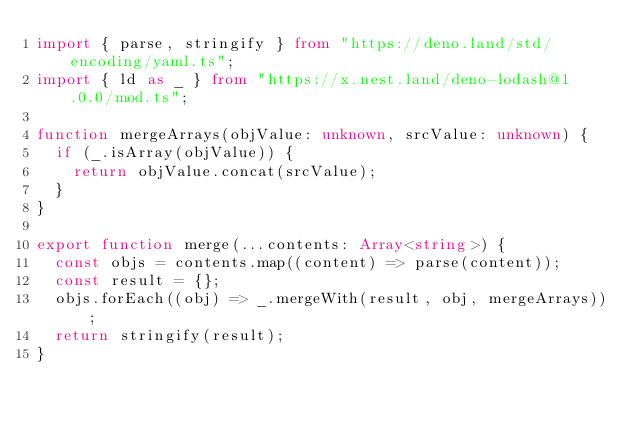<code> <loc_0><loc_0><loc_500><loc_500><_TypeScript_>import { parse, stringify } from "https://deno.land/std/encoding/yaml.ts";
import { ld as _ } from "https://x.nest.land/deno-lodash@1.0.0/mod.ts";

function mergeArrays(objValue: unknown, srcValue: unknown) {
  if (_.isArray(objValue)) {
    return objValue.concat(srcValue);
  }
}

export function merge(...contents: Array<string>) {
  const objs = contents.map((content) => parse(content));
  const result = {};
  objs.forEach((obj) => _.mergeWith(result, obj, mergeArrays));
  return stringify(result);
}
</code> 